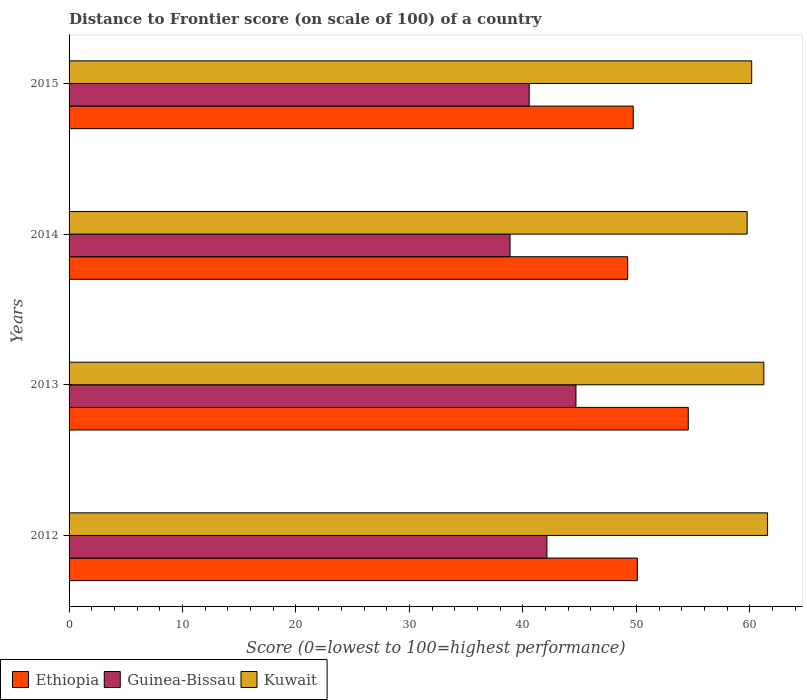How many groups of bars are there?
Make the answer very short. 4. How many bars are there on the 2nd tick from the top?
Your response must be concise. 3. How many bars are there on the 3rd tick from the bottom?
Provide a short and direct response. 3. What is the distance to frontier score of in Kuwait in 2013?
Your answer should be very brief. 61.24. Across all years, what is the maximum distance to frontier score of in Guinea-Bissau?
Ensure brevity in your answer.  44.68. Across all years, what is the minimum distance to frontier score of in Ethiopia?
Your answer should be very brief. 49.24. What is the total distance to frontier score of in Kuwait in the graph?
Provide a succinct answer. 242.75. What is the difference between the distance to frontier score of in Ethiopia in 2012 and that in 2013?
Ensure brevity in your answer.  -4.49. What is the difference between the distance to frontier score of in Guinea-Bissau in 2013 and the distance to frontier score of in Kuwait in 2015?
Provide a succinct answer. -15.49. What is the average distance to frontier score of in Ethiopia per year?
Offer a very short reply. 50.91. In the year 2014, what is the difference between the distance to frontier score of in Kuwait and distance to frontier score of in Ethiopia?
Your response must be concise. 10.53. What is the ratio of the distance to frontier score of in Guinea-Bissau in 2012 to that in 2013?
Provide a succinct answer. 0.94. Is the distance to frontier score of in Guinea-Bissau in 2013 less than that in 2015?
Your answer should be compact. No. What is the difference between the highest and the second highest distance to frontier score of in Kuwait?
Offer a terse response. 0.33. What is the difference between the highest and the lowest distance to frontier score of in Ethiopia?
Provide a short and direct response. 5.34. What does the 2nd bar from the top in 2012 represents?
Ensure brevity in your answer.  Guinea-Bissau. What does the 1st bar from the bottom in 2014 represents?
Offer a very short reply. Ethiopia. How many bars are there?
Give a very brief answer. 12. Are all the bars in the graph horizontal?
Keep it short and to the point. Yes. What is the difference between two consecutive major ticks on the X-axis?
Your response must be concise. 10. Are the values on the major ticks of X-axis written in scientific E-notation?
Your answer should be compact. No. Does the graph contain grids?
Ensure brevity in your answer.  No. How many legend labels are there?
Make the answer very short. 3. What is the title of the graph?
Offer a very short reply. Distance to Frontier score (on scale of 100) of a country. Does "Papua New Guinea" appear as one of the legend labels in the graph?
Your answer should be very brief. No. What is the label or title of the X-axis?
Provide a succinct answer. Score (0=lowest to 100=highest performance). What is the Score (0=lowest to 100=highest performance) of Ethiopia in 2012?
Keep it short and to the point. 50.09. What is the Score (0=lowest to 100=highest performance) of Guinea-Bissau in 2012?
Your answer should be compact. 42.12. What is the Score (0=lowest to 100=highest performance) of Kuwait in 2012?
Your response must be concise. 61.57. What is the Score (0=lowest to 100=highest performance) in Ethiopia in 2013?
Your answer should be very brief. 54.58. What is the Score (0=lowest to 100=highest performance) of Guinea-Bissau in 2013?
Your answer should be very brief. 44.68. What is the Score (0=lowest to 100=highest performance) in Kuwait in 2013?
Offer a terse response. 61.24. What is the Score (0=lowest to 100=highest performance) in Ethiopia in 2014?
Give a very brief answer. 49.24. What is the Score (0=lowest to 100=highest performance) of Guinea-Bissau in 2014?
Offer a very short reply. 38.87. What is the Score (0=lowest to 100=highest performance) of Kuwait in 2014?
Your answer should be compact. 59.77. What is the Score (0=lowest to 100=highest performance) of Ethiopia in 2015?
Your response must be concise. 49.73. What is the Score (0=lowest to 100=highest performance) in Guinea-Bissau in 2015?
Your answer should be compact. 40.56. What is the Score (0=lowest to 100=highest performance) in Kuwait in 2015?
Provide a short and direct response. 60.17. Across all years, what is the maximum Score (0=lowest to 100=highest performance) of Ethiopia?
Your response must be concise. 54.58. Across all years, what is the maximum Score (0=lowest to 100=highest performance) of Guinea-Bissau?
Your response must be concise. 44.68. Across all years, what is the maximum Score (0=lowest to 100=highest performance) in Kuwait?
Provide a short and direct response. 61.57. Across all years, what is the minimum Score (0=lowest to 100=highest performance) in Ethiopia?
Keep it short and to the point. 49.24. Across all years, what is the minimum Score (0=lowest to 100=highest performance) of Guinea-Bissau?
Ensure brevity in your answer.  38.87. Across all years, what is the minimum Score (0=lowest to 100=highest performance) in Kuwait?
Offer a very short reply. 59.77. What is the total Score (0=lowest to 100=highest performance) in Ethiopia in the graph?
Your response must be concise. 203.64. What is the total Score (0=lowest to 100=highest performance) in Guinea-Bissau in the graph?
Give a very brief answer. 166.23. What is the total Score (0=lowest to 100=highest performance) in Kuwait in the graph?
Make the answer very short. 242.75. What is the difference between the Score (0=lowest to 100=highest performance) in Ethiopia in 2012 and that in 2013?
Ensure brevity in your answer.  -4.49. What is the difference between the Score (0=lowest to 100=highest performance) of Guinea-Bissau in 2012 and that in 2013?
Offer a terse response. -2.56. What is the difference between the Score (0=lowest to 100=highest performance) of Kuwait in 2012 and that in 2013?
Your answer should be compact. 0.33. What is the difference between the Score (0=lowest to 100=highest performance) of Guinea-Bissau in 2012 and that in 2014?
Offer a very short reply. 3.25. What is the difference between the Score (0=lowest to 100=highest performance) of Ethiopia in 2012 and that in 2015?
Give a very brief answer. 0.36. What is the difference between the Score (0=lowest to 100=highest performance) of Guinea-Bissau in 2012 and that in 2015?
Make the answer very short. 1.56. What is the difference between the Score (0=lowest to 100=highest performance) of Kuwait in 2012 and that in 2015?
Your response must be concise. 1.4. What is the difference between the Score (0=lowest to 100=highest performance) of Ethiopia in 2013 and that in 2014?
Make the answer very short. 5.34. What is the difference between the Score (0=lowest to 100=highest performance) in Guinea-Bissau in 2013 and that in 2014?
Your response must be concise. 5.81. What is the difference between the Score (0=lowest to 100=highest performance) in Kuwait in 2013 and that in 2014?
Keep it short and to the point. 1.47. What is the difference between the Score (0=lowest to 100=highest performance) of Ethiopia in 2013 and that in 2015?
Make the answer very short. 4.85. What is the difference between the Score (0=lowest to 100=highest performance) of Guinea-Bissau in 2013 and that in 2015?
Ensure brevity in your answer.  4.12. What is the difference between the Score (0=lowest to 100=highest performance) in Kuwait in 2013 and that in 2015?
Keep it short and to the point. 1.07. What is the difference between the Score (0=lowest to 100=highest performance) in Ethiopia in 2014 and that in 2015?
Your response must be concise. -0.49. What is the difference between the Score (0=lowest to 100=highest performance) in Guinea-Bissau in 2014 and that in 2015?
Your response must be concise. -1.69. What is the difference between the Score (0=lowest to 100=highest performance) of Kuwait in 2014 and that in 2015?
Your answer should be very brief. -0.4. What is the difference between the Score (0=lowest to 100=highest performance) in Ethiopia in 2012 and the Score (0=lowest to 100=highest performance) in Guinea-Bissau in 2013?
Keep it short and to the point. 5.41. What is the difference between the Score (0=lowest to 100=highest performance) in Ethiopia in 2012 and the Score (0=lowest to 100=highest performance) in Kuwait in 2013?
Your response must be concise. -11.15. What is the difference between the Score (0=lowest to 100=highest performance) of Guinea-Bissau in 2012 and the Score (0=lowest to 100=highest performance) of Kuwait in 2013?
Keep it short and to the point. -19.12. What is the difference between the Score (0=lowest to 100=highest performance) of Ethiopia in 2012 and the Score (0=lowest to 100=highest performance) of Guinea-Bissau in 2014?
Keep it short and to the point. 11.22. What is the difference between the Score (0=lowest to 100=highest performance) in Ethiopia in 2012 and the Score (0=lowest to 100=highest performance) in Kuwait in 2014?
Keep it short and to the point. -9.68. What is the difference between the Score (0=lowest to 100=highest performance) in Guinea-Bissau in 2012 and the Score (0=lowest to 100=highest performance) in Kuwait in 2014?
Offer a very short reply. -17.65. What is the difference between the Score (0=lowest to 100=highest performance) in Ethiopia in 2012 and the Score (0=lowest to 100=highest performance) in Guinea-Bissau in 2015?
Provide a short and direct response. 9.53. What is the difference between the Score (0=lowest to 100=highest performance) in Ethiopia in 2012 and the Score (0=lowest to 100=highest performance) in Kuwait in 2015?
Give a very brief answer. -10.08. What is the difference between the Score (0=lowest to 100=highest performance) in Guinea-Bissau in 2012 and the Score (0=lowest to 100=highest performance) in Kuwait in 2015?
Your answer should be compact. -18.05. What is the difference between the Score (0=lowest to 100=highest performance) in Ethiopia in 2013 and the Score (0=lowest to 100=highest performance) in Guinea-Bissau in 2014?
Make the answer very short. 15.71. What is the difference between the Score (0=lowest to 100=highest performance) in Ethiopia in 2013 and the Score (0=lowest to 100=highest performance) in Kuwait in 2014?
Provide a succinct answer. -5.19. What is the difference between the Score (0=lowest to 100=highest performance) of Guinea-Bissau in 2013 and the Score (0=lowest to 100=highest performance) of Kuwait in 2014?
Your answer should be very brief. -15.09. What is the difference between the Score (0=lowest to 100=highest performance) in Ethiopia in 2013 and the Score (0=lowest to 100=highest performance) in Guinea-Bissau in 2015?
Your answer should be compact. 14.02. What is the difference between the Score (0=lowest to 100=highest performance) in Ethiopia in 2013 and the Score (0=lowest to 100=highest performance) in Kuwait in 2015?
Your answer should be very brief. -5.59. What is the difference between the Score (0=lowest to 100=highest performance) of Guinea-Bissau in 2013 and the Score (0=lowest to 100=highest performance) of Kuwait in 2015?
Keep it short and to the point. -15.49. What is the difference between the Score (0=lowest to 100=highest performance) in Ethiopia in 2014 and the Score (0=lowest to 100=highest performance) in Guinea-Bissau in 2015?
Give a very brief answer. 8.68. What is the difference between the Score (0=lowest to 100=highest performance) in Ethiopia in 2014 and the Score (0=lowest to 100=highest performance) in Kuwait in 2015?
Provide a succinct answer. -10.93. What is the difference between the Score (0=lowest to 100=highest performance) of Guinea-Bissau in 2014 and the Score (0=lowest to 100=highest performance) of Kuwait in 2015?
Your answer should be compact. -21.3. What is the average Score (0=lowest to 100=highest performance) in Ethiopia per year?
Provide a short and direct response. 50.91. What is the average Score (0=lowest to 100=highest performance) in Guinea-Bissau per year?
Ensure brevity in your answer.  41.56. What is the average Score (0=lowest to 100=highest performance) in Kuwait per year?
Make the answer very short. 60.69. In the year 2012, what is the difference between the Score (0=lowest to 100=highest performance) in Ethiopia and Score (0=lowest to 100=highest performance) in Guinea-Bissau?
Make the answer very short. 7.97. In the year 2012, what is the difference between the Score (0=lowest to 100=highest performance) of Ethiopia and Score (0=lowest to 100=highest performance) of Kuwait?
Ensure brevity in your answer.  -11.48. In the year 2012, what is the difference between the Score (0=lowest to 100=highest performance) of Guinea-Bissau and Score (0=lowest to 100=highest performance) of Kuwait?
Offer a terse response. -19.45. In the year 2013, what is the difference between the Score (0=lowest to 100=highest performance) in Ethiopia and Score (0=lowest to 100=highest performance) in Kuwait?
Your response must be concise. -6.66. In the year 2013, what is the difference between the Score (0=lowest to 100=highest performance) of Guinea-Bissau and Score (0=lowest to 100=highest performance) of Kuwait?
Make the answer very short. -16.56. In the year 2014, what is the difference between the Score (0=lowest to 100=highest performance) in Ethiopia and Score (0=lowest to 100=highest performance) in Guinea-Bissau?
Provide a succinct answer. 10.37. In the year 2014, what is the difference between the Score (0=lowest to 100=highest performance) in Ethiopia and Score (0=lowest to 100=highest performance) in Kuwait?
Give a very brief answer. -10.53. In the year 2014, what is the difference between the Score (0=lowest to 100=highest performance) in Guinea-Bissau and Score (0=lowest to 100=highest performance) in Kuwait?
Ensure brevity in your answer.  -20.9. In the year 2015, what is the difference between the Score (0=lowest to 100=highest performance) in Ethiopia and Score (0=lowest to 100=highest performance) in Guinea-Bissau?
Your response must be concise. 9.17. In the year 2015, what is the difference between the Score (0=lowest to 100=highest performance) in Ethiopia and Score (0=lowest to 100=highest performance) in Kuwait?
Ensure brevity in your answer.  -10.44. In the year 2015, what is the difference between the Score (0=lowest to 100=highest performance) in Guinea-Bissau and Score (0=lowest to 100=highest performance) in Kuwait?
Your response must be concise. -19.61. What is the ratio of the Score (0=lowest to 100=highest performance) in Ethiopia in 2012 to that in 2013?
Offer a very short reply. 0.92. What is the ratio of the Score (0=lowest to 100=highest performance) in Guinea-Bissau in 2012 to that in 2013?
Keep it short and to the point. 0.94. What is the ratio of the Score (0=lowest to 100=highest performance) of Kuwait in 2012 to that in 2013?
Offer a very short reply. 1.01. What is the ratio of the Score (0=lowest to 100=highest performance) of Ethiopia in 2012 to that in 2014?
Make the answer very short. 1.02. What is the ratio of the Score (0=lowest to 100=highest performance) of Guinea-Bissau in 2012 to that in 2014?
Ensure brevity in your answer.  1.08. What is the ratio of the Score (0=lowest to 100=highest performance) in Kuwait in 2012 to that in 2014?
Ensure brevity in your answer.  1.03. What is the ratio of the Score (0=lowest to 100=highest performance) in Guinea-Bissau in 2012 to that in 2015?
Ensure brevity in your answer.  1.04. What is the ratio of the Score (0=lowest to 100=highest performance) of Kuwait in 2012 to that in 2015?
Ensure brevity in your answer.  1.02. What is the ratio of the Score (0=lowest to 100=highest performance) of Ethiopia in 2013 to that in 2014?
Give a very brief answer. 1.11. What is the ratio of the Score (0=lowest to 100=highest performance) of Guinea-Bissau in 2013 to that in 2014?
Offer a terse response. 1.15. What is the ratio of the Score (0=lowest to 100=highest performance) in Kuwait in 2013 to that in 2014?
Your answer should be very brief. 1.02. What is the ratio of the Score (0=lowest to 100=highest performance) in Ethiopia in 2013 to that in 2015?
Provide a succinct answer. 1.1. What is the ratio of the Score (0=lowest to 100=highest performance) in Guinea-Bissau in 2013 to that in 2015?
Ensure brevity in your answer.  1.1. What is the ratio of the Score (0=lowest to 100=highest performance) of Kuwait in 2013 to that in 2015?
Your answer should be compact. 1.02. What is the ratio of the Score (0=lowest to 100=highest performance) in Guinea-Bissau in 2014 to that in 2015?
Make the answer very short. 0.96. What is the difference between the highest and the second highest Score (0=lowest to 100=highest performance) in Ethiopia?
Offer a terse response. 4.49. What is the difference between the highest and the second highest Score (0=lowest to 100=highest performance) in Guinea-Bissau?
Make the answer very short. 2.56. What is the difference between the highest and the second highest Score (0=lowest to 100=highest performance) of Kuwait?
Offer a very short reply. 0.33. What is the difference between the highest and the lowest Score (0=lowest to 100=highest performance) of Ethiopia?
Offer a terse response. 5.34. What is the difference between the highest and the lowest Score (0=lowest to 100=highest performance) of Guinea-Bissau?
Offer a terse response. 5.81. What is the difference between the highest and the lowest Score (0=lowest to 100=highest performance) in Kuwait?
Your answer should be compact. 1.8. 